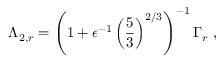<formula> <loc_0><loc_0><loc_500><loc_500>\Lambda _ { 2 , r } = \left ( 1 + \epsilon ^ { - 1 } \left ( \frac { 5 } { 3 } \right ) ^ { 2 / 3 } \right ) ^ { - 1 } \Gamma _ { r } \ ,</formula> 